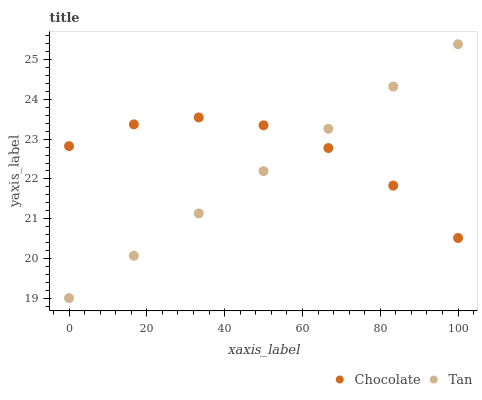Does Tan have the minimum area under the curve?
Answer yes or no. Yes. Does Chocolate have the maximum area under the curve?
Answer yes or no. Yes. Does Chocolate have the minimum area under the curve?
Answer yes or no. No. Is Tan the smoothest?
Answer yes or no. Yes. Is Chocolate the roughest?
Answer yes or no. Yes. Is Chocolate the smoothest?
Answer yes or no. No. Does Tan have the lowest value?
Answer yes or no. Yes. Does Chocolate have the lowest value?
Answer yes or no. No. Does Tan have the highest value?
Answer yes or no. Yes. Does Chocolate have the highest value?
Answer yes or no. No. Does Tan intersect Chocolate?
Answer yes or no. Yes. Is Tan less than Chocolate?
Answer yes or no. No. Is Tan greater than Chocolate?
Answer yes or no. No. 